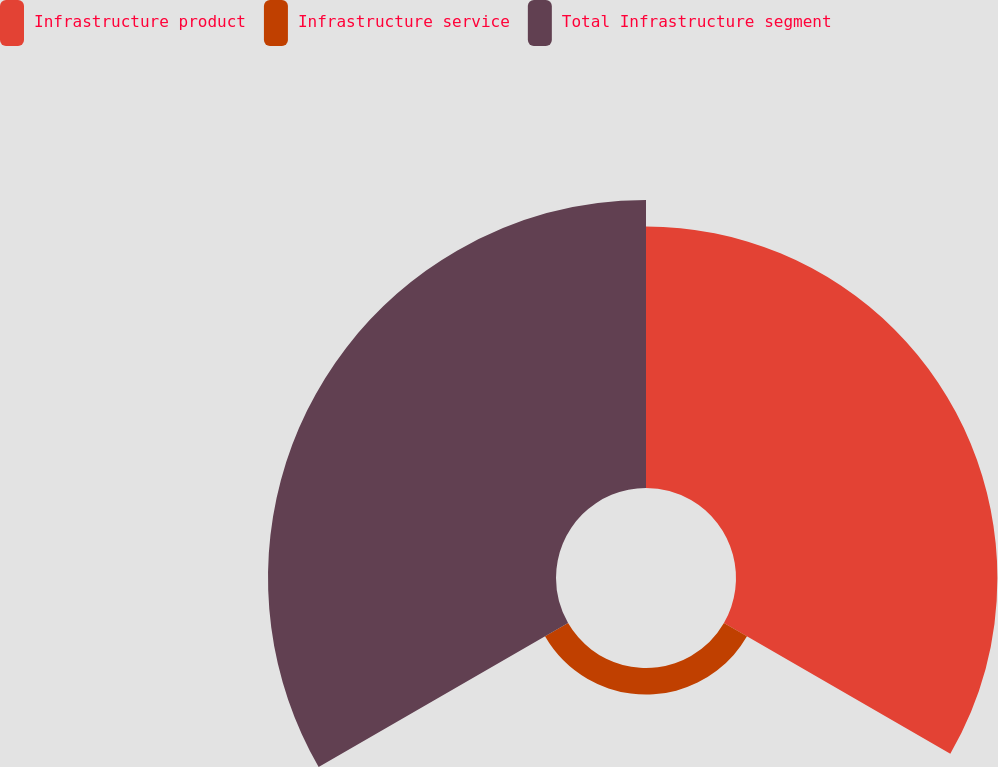Convert chart. <chart><loc_0><loc_0><loc_500><loc_500><pie_chart><fcel>Infrastructure product<fcel>Infrastructure service<fcel>Total Infrastructure segment<nl><fcel>45.38%<fcel>4.62%<fcel>50.0%<nl></chart> 